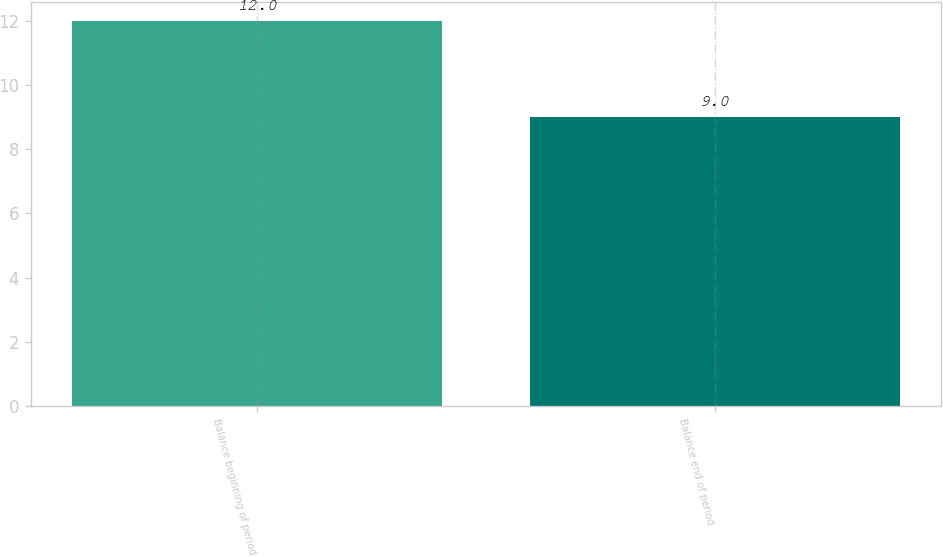Convert chart. <chart><loc_0><loc_0><loc_500><loc_500><bar_chart><fcel>Balance beginning of period<fcel>Balance end of period<nl><fcel>12<fcel>9<nl></chart> 